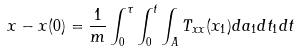<formula> <loc_0><loc_0><loc_500><loc_500>x - x ( 0 ) = \frac { 1 } { m } \int _ { 0 } ^ { \tau } \int _ { 0 } ^ { t } \int _ { A } T _ { x x } ( x _ { 1 } ) d a _ { 1 } d t _ { 1 } d t</formula> 